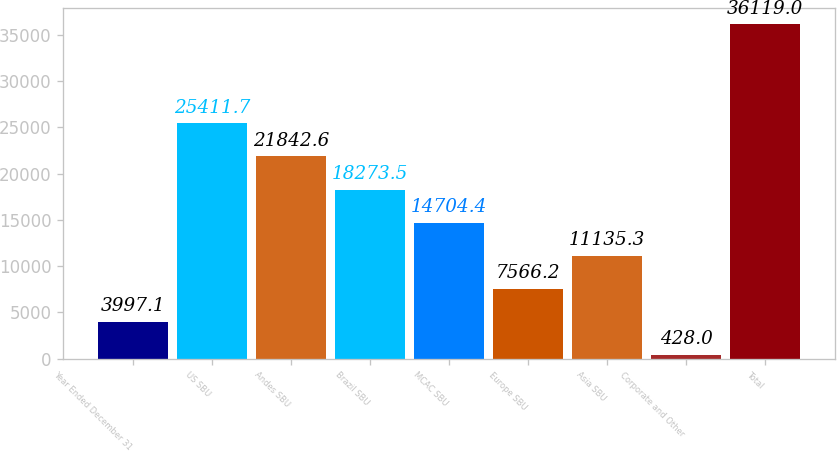Convert chart to OTSL. <chart><loc_0><loc_0><loc_500><loc_500><bar_chart><fcel>Year Ended December 31<fcel>US SBU<fcel>Andes SBU<fcel>Brazil SBU<fcel>MCAC SBU<fcel>Europe SBU<fcel>Asia SBU<fcel>Corporate and Other<fcel>Total<nl><fcel>3997.1<fcel>25411.7<fcel>21842.6<fcel>18273.5<fcel>14704.4<fcel>7566.2<fcel>11135.3<fcel>428<fcel>36119<nl></chart> 